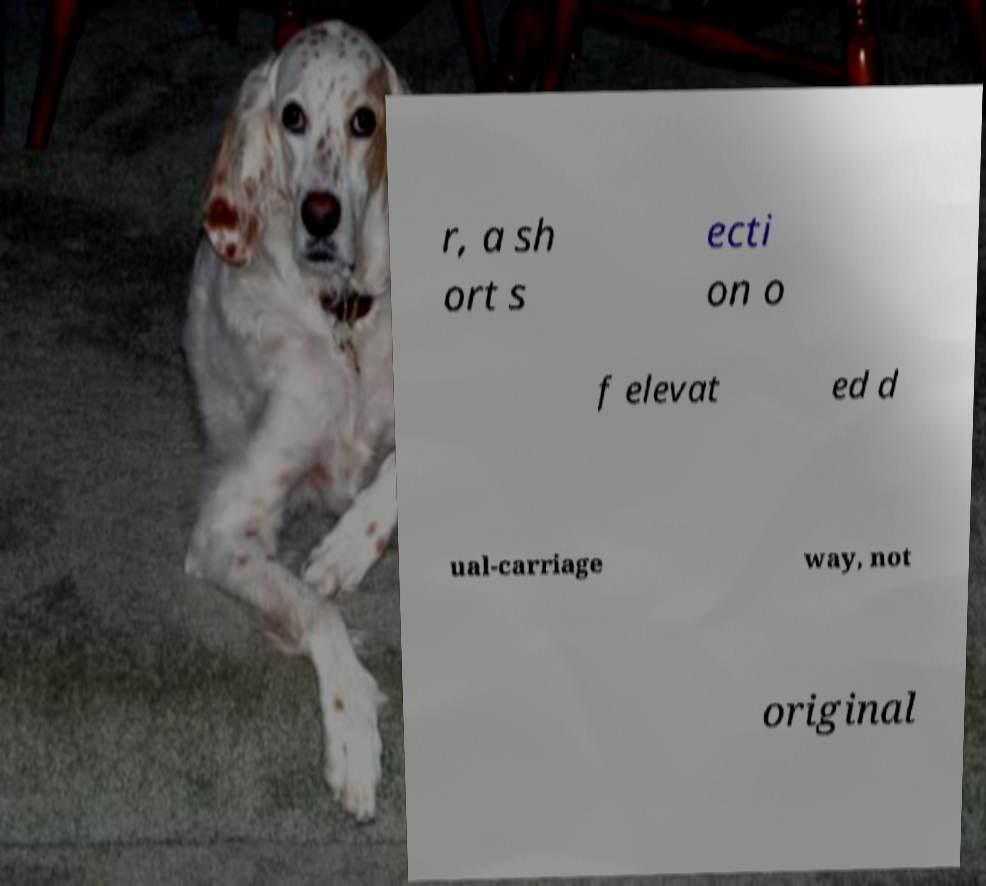Can you read and provide the text displayed in the image?This photo seems to have some interesting text. Can you extract and type it out for me? r, a sh ort s ecti on o f elevat ed d ual-carriage way, not original 